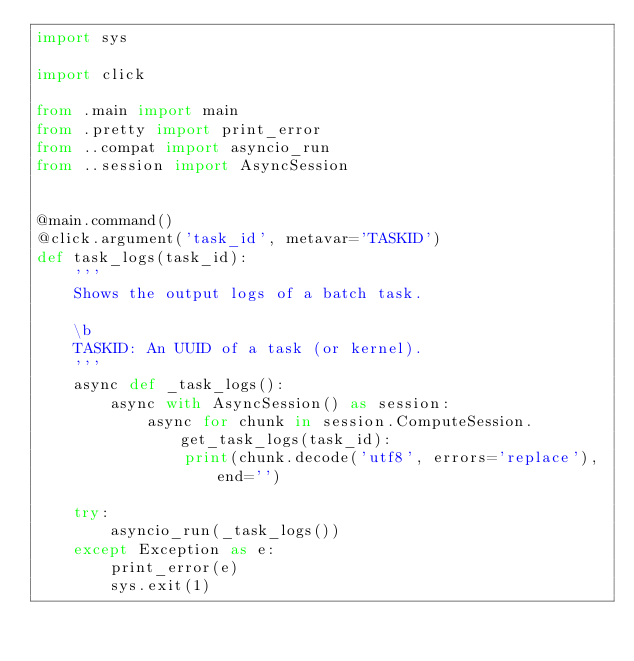Convert code to text. <code><loc_0><loc_0><loc_500><loc_500><_Python_>import sys

import click

from .main import main
from .pretty import print_error
from ..compat import asyncio_run
from ..session import AsyncSession


@main.command()
@click.argument('task_id', metavar='TASKID')
def task_logs(task_id):
    '''
    Shows the output logs of a batch task.

    \b
    TASKID: An UUID of a task (or kernel).
    '''
    async def _task_logs():
        async with AsyncSession() as session:
            async for chunk in session.ComputeSession.get_task_logs(task_id):
                print(chunk.decode('utf8', errors='replace'), end='')

    try:
        asyncio_run(_task_logs())
    except Exception as e:
        print_error(e)
        sys.exit(1)
</code> 